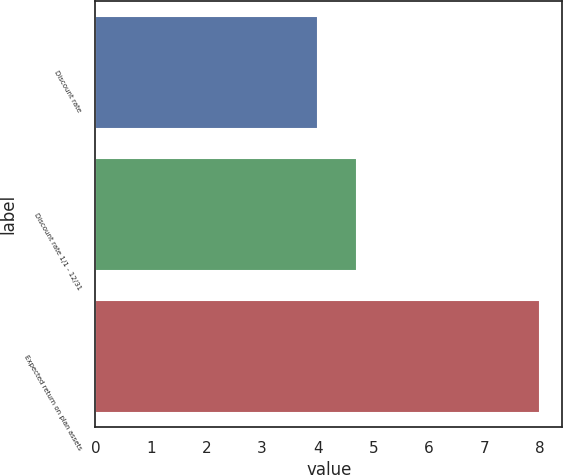Convert chart to OTSL. <chart><loc_0><loc_0><loc_500><loc_500><bar_chart><fcel>Discount rate<fcel>Discount rate 1/1 - 12/31<fcel>Expected return on plan assets<nl><fcel>4<fcel>4.71<fcel>8<nl></chart> 